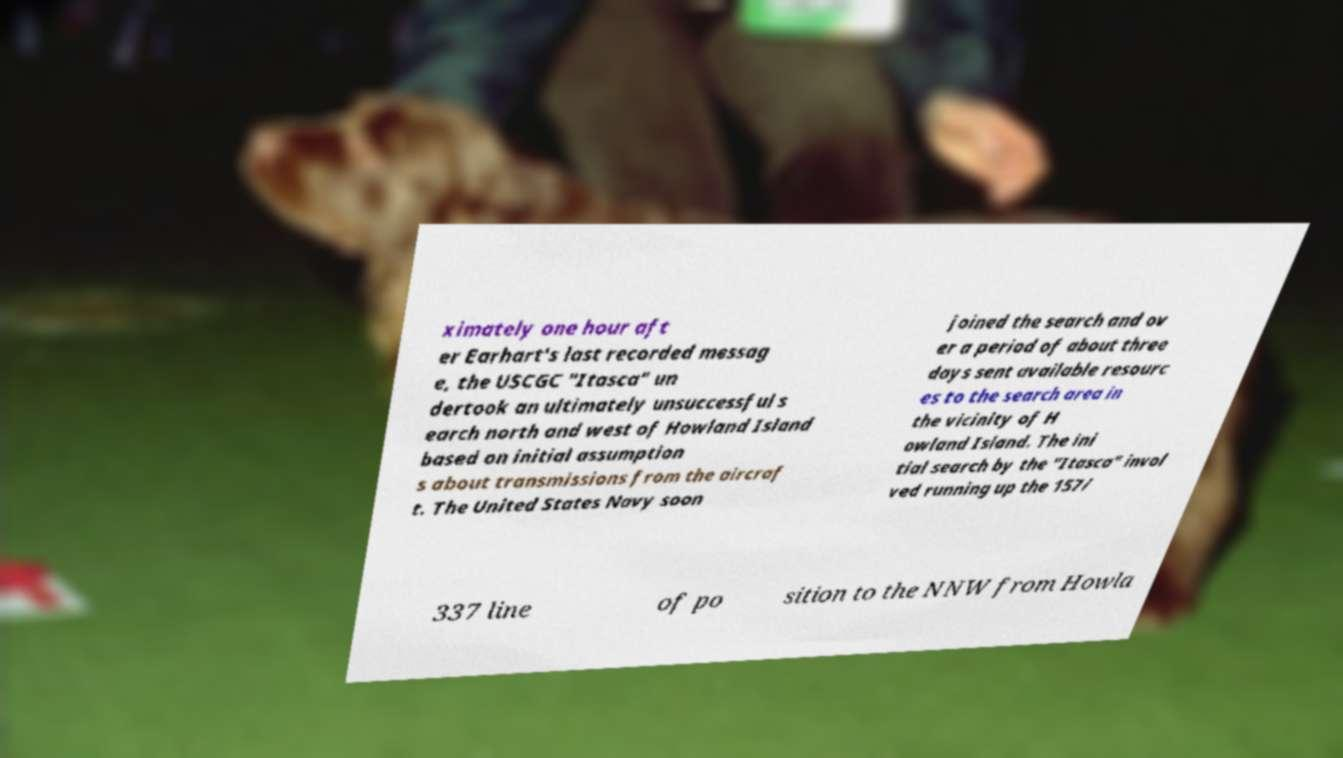What messages or text are displayed in this image? I need them in a readable, typed format. ximately one hour aft er Earhart's last recorded messag e, the USCGC "Itasca" un dertook an ultimately unsuccessful s earch north and west of Howland Island based on initial assumption s about transmissions from the aircraf t. The United States Navy soon joined the search and ov er a period of about three days sent available resourc es to the search area in the vicinity of H owland Island. The ini tial search by the "Itasca" invol ved running up the 157/ 337 line of po sition to the NNW from Howla 